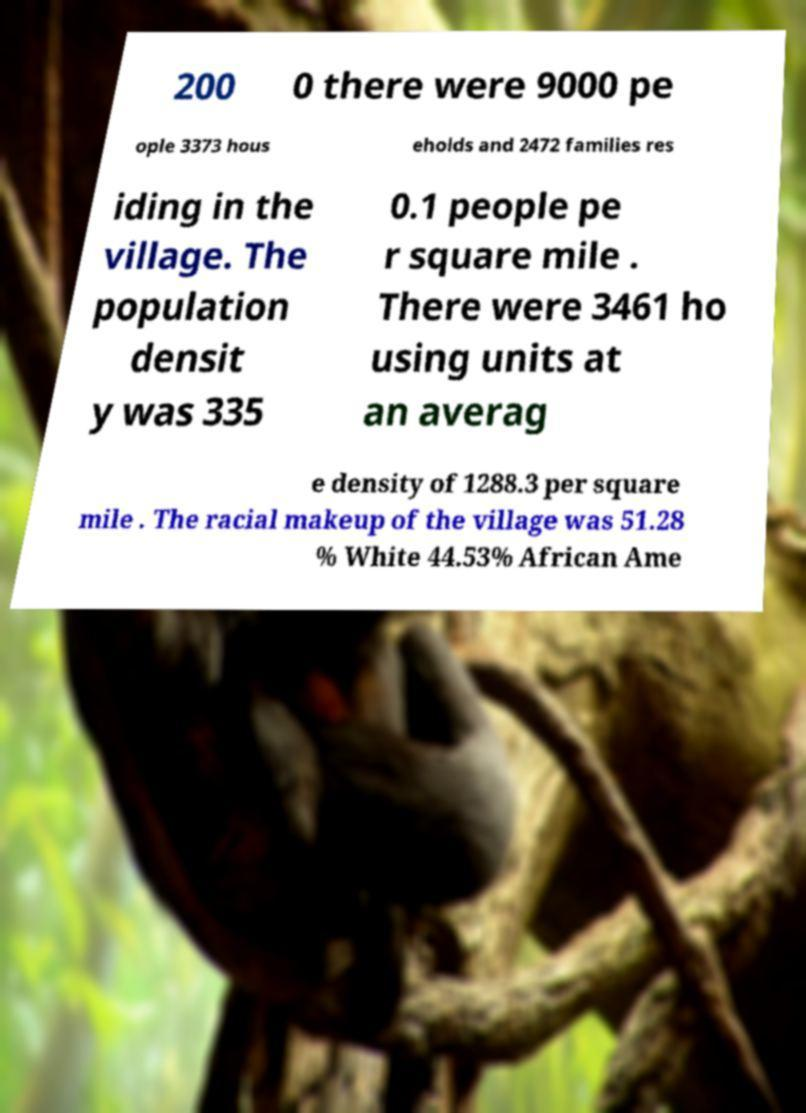I need the written content from this picture converted into text. Can you do that? 200 0 there were 9000 pe ople 3373 hous eholds and 2472 families res iding in the village. The population densit y was 335 0.1 people pe r square mile . There were 3461 ho using units at an averag e density of 1288.3 per square mile . The racial makeup of the village was 51.28 % White 44.53% African Ame 